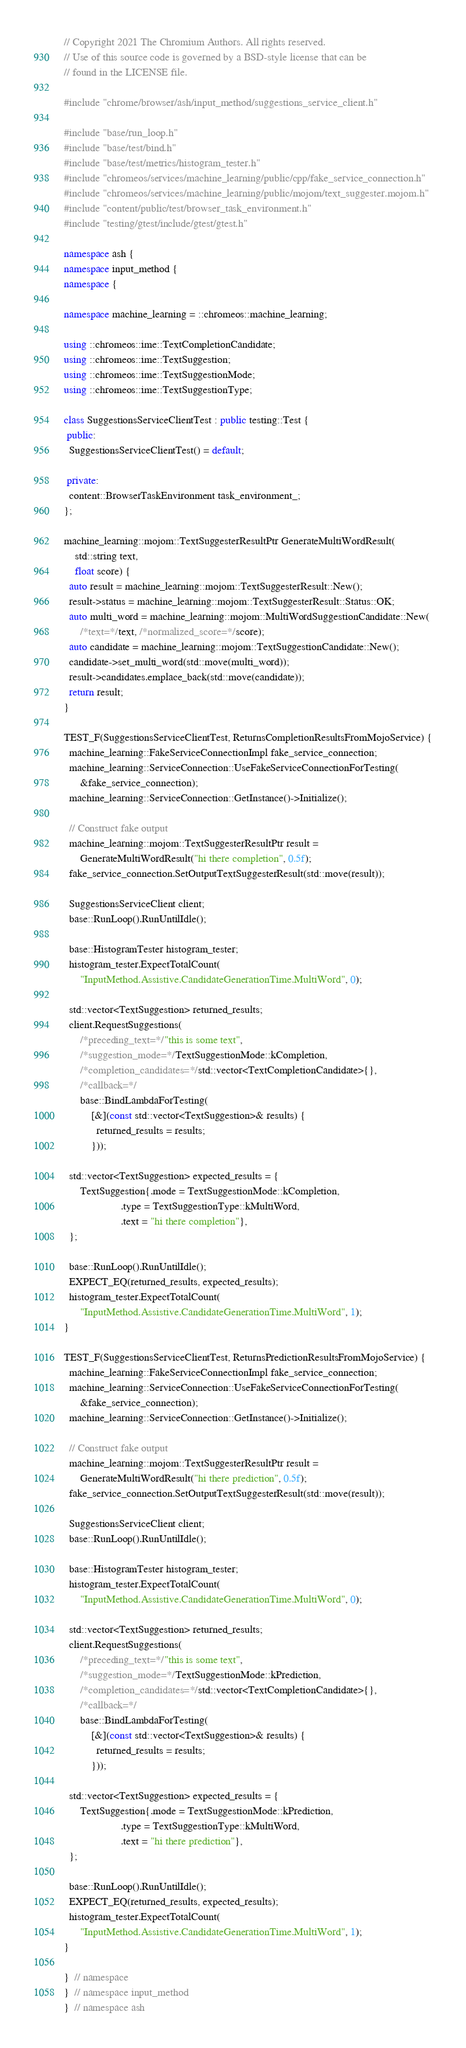<code> <loc_0><loc_0><loc_500><loc_500><_C++_>// Copyright 2021 The Chromium Authors. All rights reserved.
// Use of this source code is governed by a BSD-style license that can be
// found in the LICENSE file.

#include "chrome/browser/ash/input_method/suggestions_service_client.h"

#include "base/run_loop.h"
#include "base/test/bind.h"
#include "base/test/metrics/histogram_tester.h"
#include "chromeos/services/machine_learning/public/cpp/fake_service_connection.h"
#include "chromeos/services/machine_learning/public/mojom/text_suggester.mojom.h"
#include "content/public/test/browser_task_environment.h"
#include "testing/gtest/include/gtest/gtest.h"

namespace ash {
namespace input_method {
namespace {

namespace machine_learning = ::chromeos::machine_learning;

using ::chromeos::ime::TextCompletionCandidate;
using ::chromeos::ime::TextSuggestion;
using ::chromeos::ime::TextSuggestionMode;
using ::chromeos::ime::TextSuggestionType;

class SuggestionsServiceClientTest : public testing::Test {
 public:
  SuggestionsServiceClientTest() = default;

 private:
  content::BrowserTaskEnvironment task_environment_;
};

machine_learning::mojom::TextSuggesterResultPtr GenerateMultiWordResult(
    std::string text,
    float score) {
  auto result = machine_learning::mojom::TextSuggesterResult::New();
  result->status = machine_learning::mojom::TextSuggesterResult::Status::OK;
  auto multi_word = machine_learning::mojom::MultiWordSuggestionCandidate::New(
      /*text=*/text, /*normalized_score=*/score);
  auto candidate = machine_learning::mojom::TextSuggestionCandidate::New();
  candidate->set_multi_word(std::move(multi_word));
  result->candidates.emplace_back(std::move(candidate));
  return result;
}

TEST_F(SuggestionsServiceClientTest, ReturnsCompletionResultsFromMojoService) {
  machine_learning::FakeServiceConnectionImpl fake_service_connection;
  machine_learning::ServiceConnection::UseFakeServiceConnectionForTesting(
      &fake_service_connection);
  machine_learning::ServiceConnection::GetInstance()->Initialize();

  // Construct fake output
  machine_learning::mojom::TextSuggesterResultPtr result =
      GenerateMultiWordResult("hi there completion", 0.5f);
  fake_service_connection.SetOutputTextSuggesterResult(std::move(result));

  SuggestionsServiceClient client;
  base::RunLoop().RunUntilIdle();

  base::HistogramTester histogram_tester;
  histogram_tester.ExpectTotalCount(
      "InputMethod.Assistive.CandidateGenerationTime.MultiWord", 0);

  std::vector<TextSuggestion> returned_results;
  client.RequestSuggestions(
      /*preceding_text=*/"this is some text",
      /*suggestion_mode=*/TextSuggestionMode::kCompletion,
      /*completion_candidates=*/std::vector<TextCompletionCandidate>{},
      /*callback=*/
      base::BindLambdaForTesting(
          [&](const std::vector<TextSuggestion>& results) {
            returned_results = results;
          }));

  std::vector<TextSuggestion> expected_results = {
      TextSuggestion{.mode = TextSuggestionMode::kCompletion,
                     .type = TextSuggestionType::kMultiWord,
                     .text = "hi there completion"},
  };

  base::RunLoop().RunUntilIdle();
  EXPECT_EQ(returned_results, expected_results);
  histogram_tester.ExpectTotalCount(
      "InputMethod.Assistive.CandidateGenerationTime.MultiWord", 1);
}

TEST_F(SuggestionsServiceClientTest, ReturnsPredictionResultsFromMojoService) {
  machine_learning::FakeServiceConnectionImpl fake_service_connection;
  machine_learning::ServiceConnection::UseFakeServiceConnectionForTesting(
      &fake_service_connection);
  machine_learning::ServiceConnection::GetInstance()->Initialize();

  // Construct fake output
  machine_learning::mojom::TextSuggesterResultPtr result =
      GenerateMultiWordResult("hi there prediction", 0.5f);
  fake_service_connection.SetOutputTextSuggesterResult(std::move(result));

  SuggestionsServiceClient client;
  base::RunLoop().RunUntilIdle();

  base::HistogramTester histogram_tester;
  histogram_tester.ExpectTotalCount(
      "InputMethod.Assistive.CandidateGenerationTime.MultiWord", 0);

  std::vector<TextSuggestion> returned_results;
  client.RequestSuggestions(
      /*preceding_text=*/"this is some text",
      /*suggestion_mode=*/TextSuggestionMode::kPrediction,
      /*completion_candidates=*/std::vector<TextCompletionCandidate>{},
      /*callback=*/
      base::BindLambdaForTesting(
          [&](const std::vector<TextSuggestion>& results) {
            returned_results = results;
          }));

  std::vector<TextSuggestion> expected_results = {
      TextSuggestion{.mode = TextSuggestionMode::kPrediction,
                     .type = TextSuggestionType::kMultiWord,
                     .text = "hi there prediction"},
  };

  base::RunLoop().RunUntilIdle();
  EXPECT_EQ(returned_results, expected_results);
  histogram_tester.ExpectTotalCount(
      "InputMethod.Assistive.CandidateGenerationTime.MultiWord", 1);
}

}  // namespace
}  // namespace input_method
}  // namespace ash
</code> 